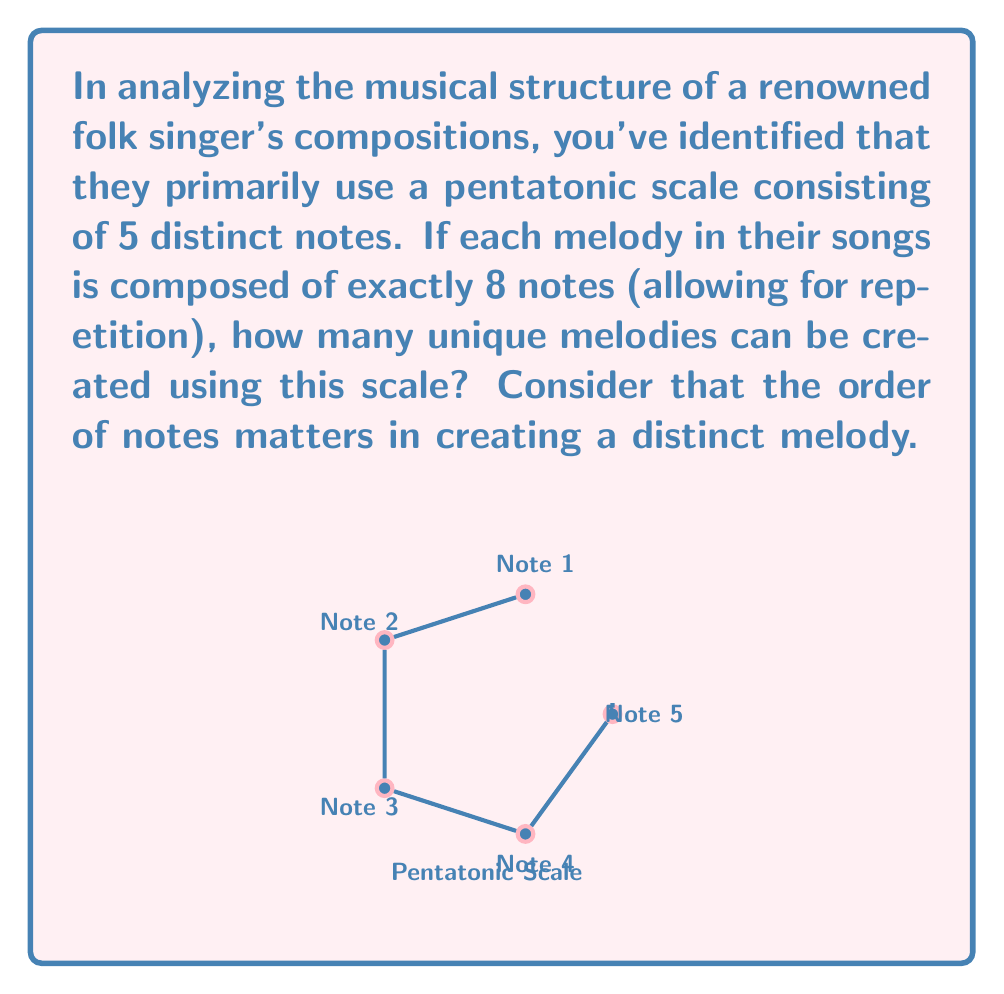Could you help me with this problem? To solve this problem, we need to use the concept of permutations with repetition. Here's a step-by-step explanation:

1) We have 5 distinct notes in our pentatonic scale, and we're creating melodies of 8 notes long.

2) For each position in the melody, we have 5 choices (any of the 5 notes can be used).

3) Since the order matters (changing the order of notes changes the melody) and repetition is allowed (we can use the same note multiple times), this is a case of permutation with repetition.

4) The formula for permutations with repetition is:

   $$n^r$$

   Where $n$ is the number of options for each position, and $r$ is the number of positions.

5) In this case, $n = 5$ (5 notes to choose from) and $r = 8$ (8 positions in the melody).

6) Therefore, the number of unique melodies is:

   $$5^8 = 390,625$$

This means that using this 5-note pentatonic scale, the folk singer has 390,625 unique 8-note melodies at their disposal, showcasing the vast creative potential even within a seemingly limited musical framework.
Answer: $5^8 = 390,625$ unique melodies 